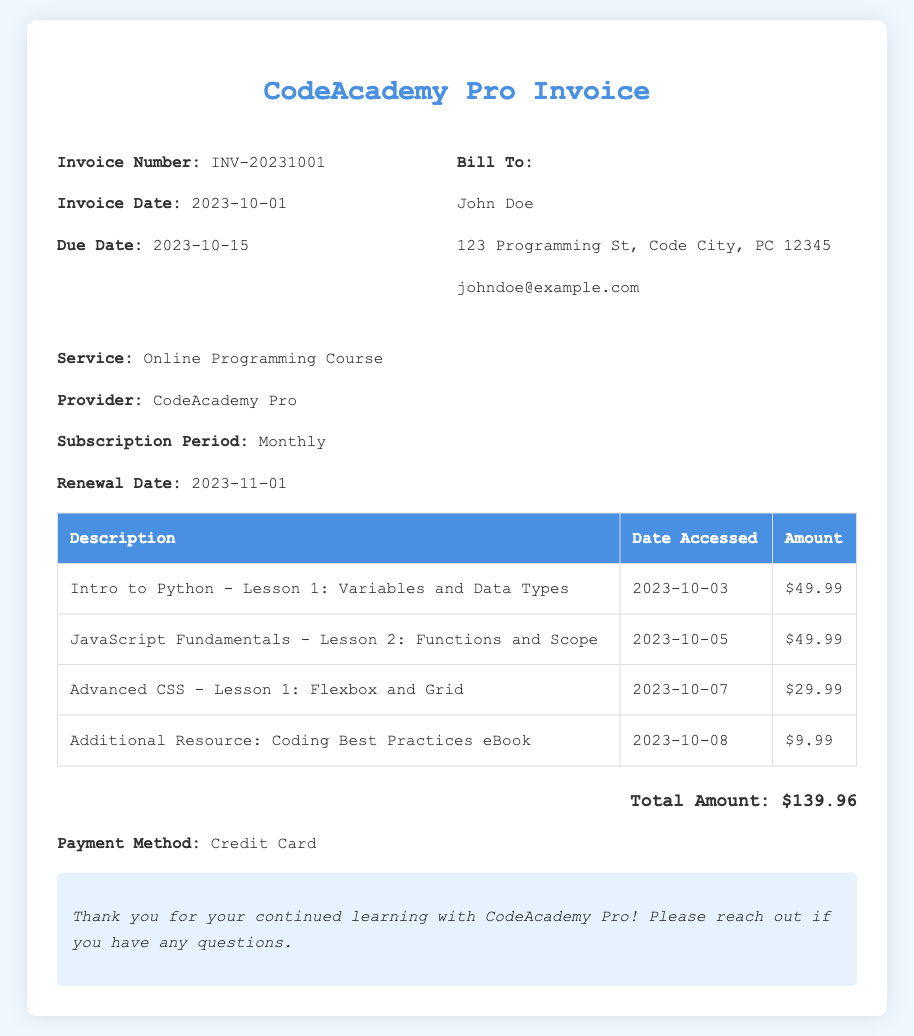What is the invoice number? The invoice number is specifically stated in the header of the document as INV-20231001.
Answer: INV-20231001 What is the invoice due date? The due date for payment is indicated clearly in the document as 2023-10-15.
Answer: 2023-10-15 Who is the invoice billed to? The billing information includes the name of the billed individual, which is stated as John Doe.
Answer: John Doe What is the total amount due? The total amount due is summarized at the bottom of the document, which shows $139.96.
Answer: $139.96 What payment method is used? The document specifies the payment method as Credit Card.
Answer: Credit Card How many lessons were accessed this month? There are four line items in the table representing lessons and resources accessed during the month.
Answer: Four What is the most expensive lesson accessed? The most expensive lesson accessed, as per the line items listed, is Intro to Python - Lesson 1: Variables and Data Types for $49.99.
Answer: $49.99 What additional resource was purchased? The document lists an additional resource, specifically Coding Best Practices eBook.
Answer: Coding Best Practices eBook When is the subscription renewal date? The renewal date for the subscription is noted in the document as 2023-11-01.
Answer: 2023-11-01 